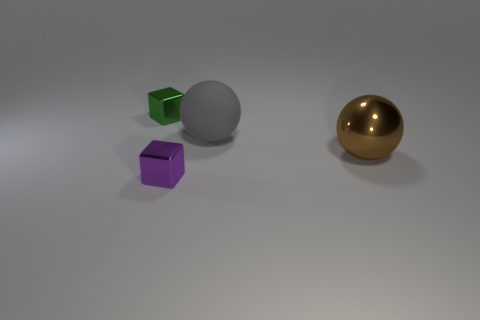Add 3 big shiny spheres. How many objects exist? 7 Subtract all brown things. Subtract all large things. How many objects are left? 1 Add 1 brown things. How many brown things are left? 2 Add 1 tiny green metallic blocks. How many tiny green metallic blocks exist? 2 Subtract 0 blue cubes. How many objects are left? 4 